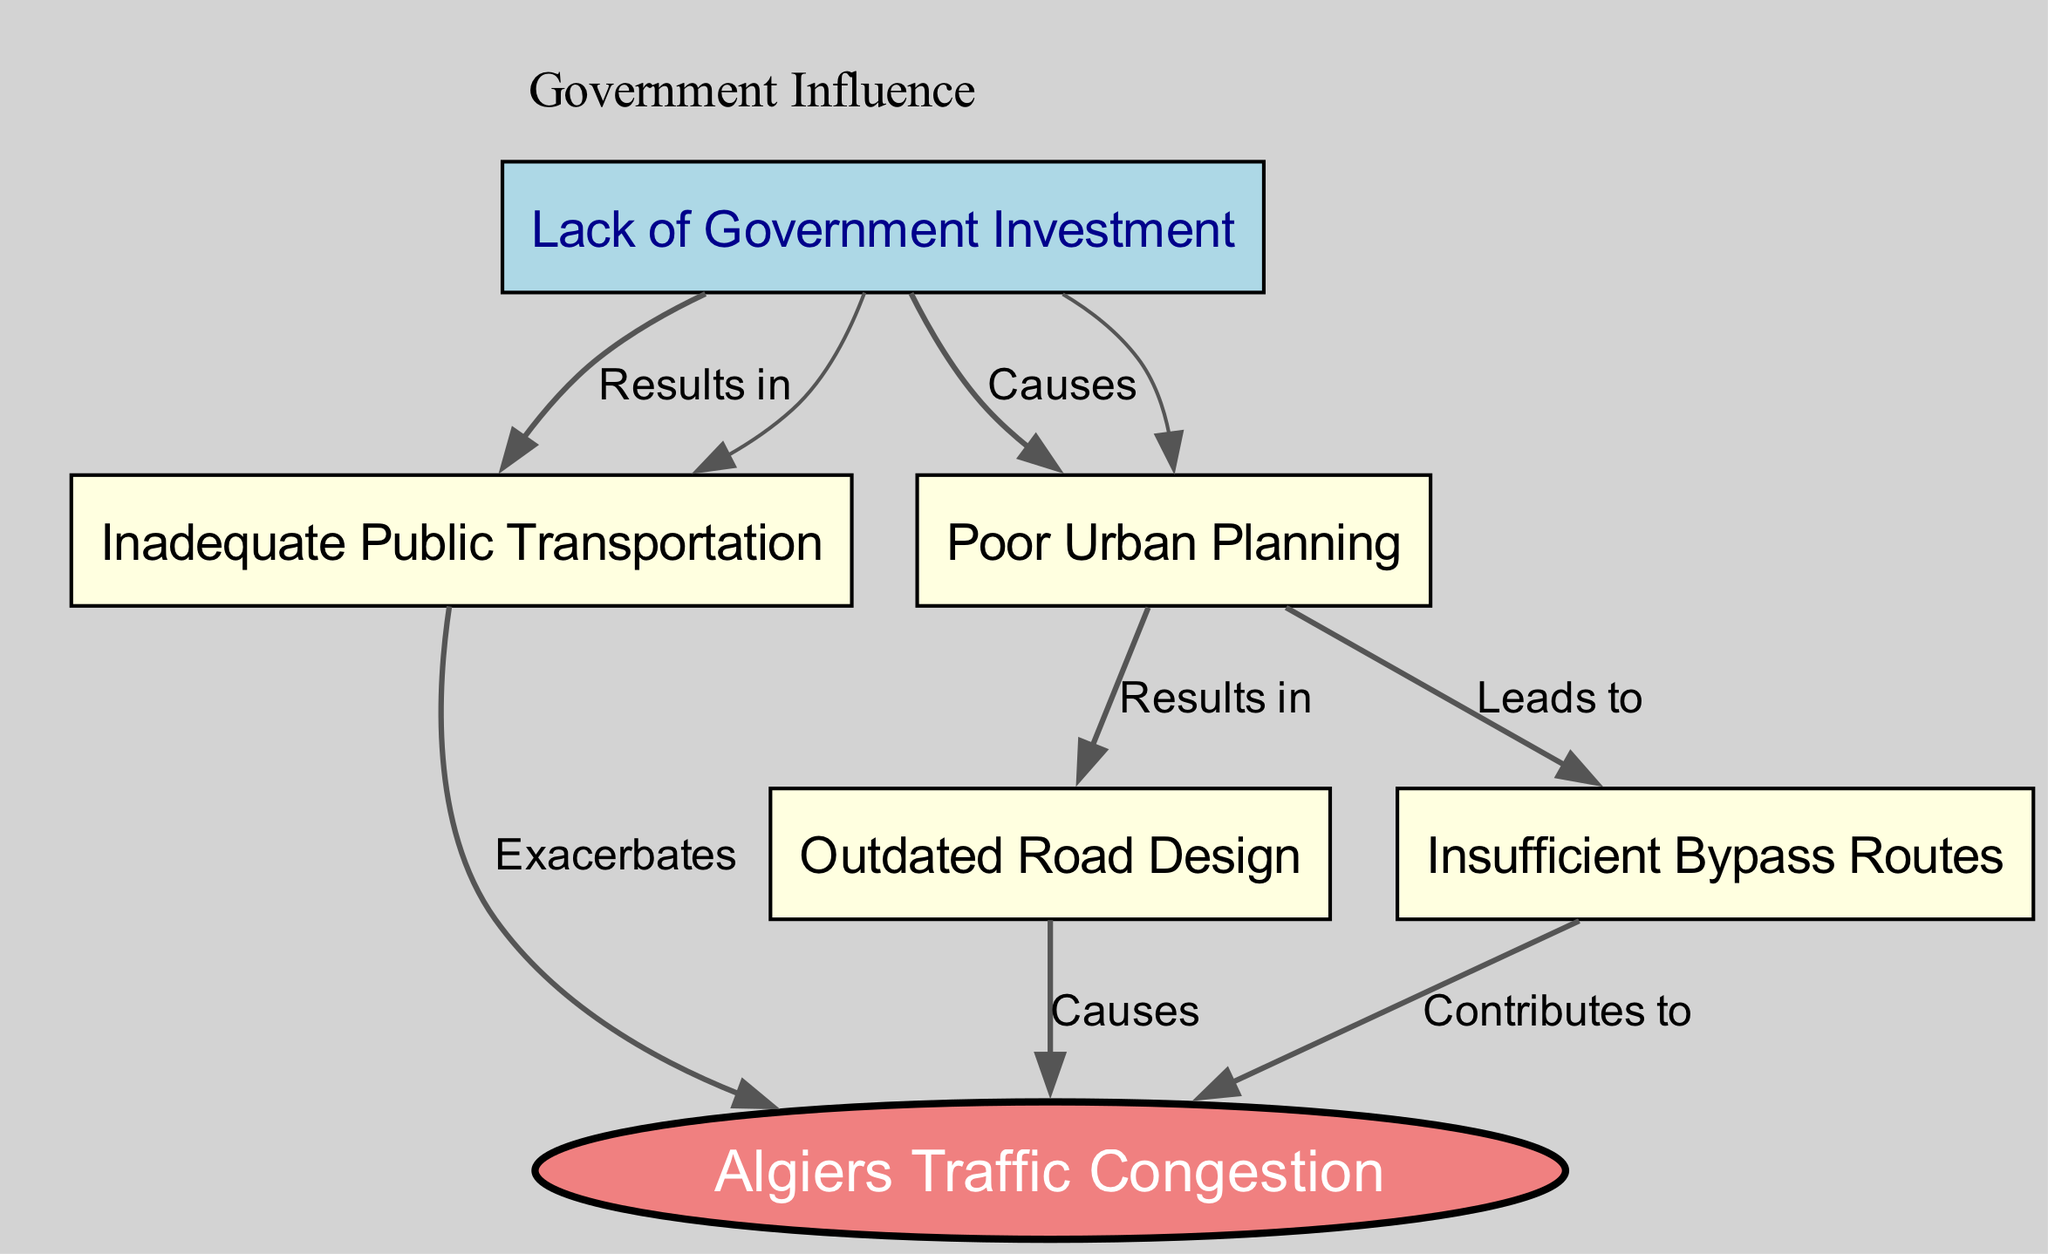What is the main issue depicted in the diagram? The diagram emphasizes "Algiers Traffic Congestion" as the main issue affecting the city. This is clearly indicated as the central node from which other contributing factors branch out.
Answer: Algiers Traffic Congestion How many nodes are present in the diagram? By counting each distinct entity represented in the diagram, we find that there are a total of six nodes labeled from "Algiers Traffic Congestion" to "Lack of Government Investment."
Answer: 6 What does "Outdated Road Design" cause? The edge labeled "Causes" connecting "Outdated Road Design" to "Algiers Traffic Congestion" indicates that outdated road design is a primary contributing factor to the congestion issue.
Answer: Causes Which factor exacerbates the congestion problem? The edge labeled "Exacerbates" illustrates that "Inadequate Public Transportation" worsens the traffic congestion situation in Algiers.
Answer: Inadequate Public Transportation What leads to "Insufficient Bypass Routes"? The edge labeled "Leads to" shows that "Poor Urban Planning" is responsible for contributing to the lack of adequate bypass routes. Thus, poor planning is directly linked to this issue.
Answer: Poor Urban Planning How does "Lack of Government Investment" relate to public transportation? The label "Results in" connecting "Lack of Government Investment" to "Inadequate Public Transportation" signifies that insufficient investment from the government directly results in poor public transportation services.
Answer: Results in What type of node is "Lack of Government Investment"? This node is categorized as a separate type compared to the others; it is depicted in a blue color, denoting its specific role as a government-related cause for issues in urban infrastructure.
Answer: Government-related node How many connections does "Inadequate Public Transportation" have? By analyzing the edges connected to "Inadequate Public Transportation," we find that it has one connection leading to "Algiers Traffic Congestion," indicating it exacerbates this issue.
Answer: 1 What component causes "Poor Urban Planning"? Inspecting the diagram, "Lack of Government Investment" is shown to cause "Poor Urban Planning," denoted by the edge labeled "Causes." This implies a direct influence of government actions on planning issues.
Answer: Causes 